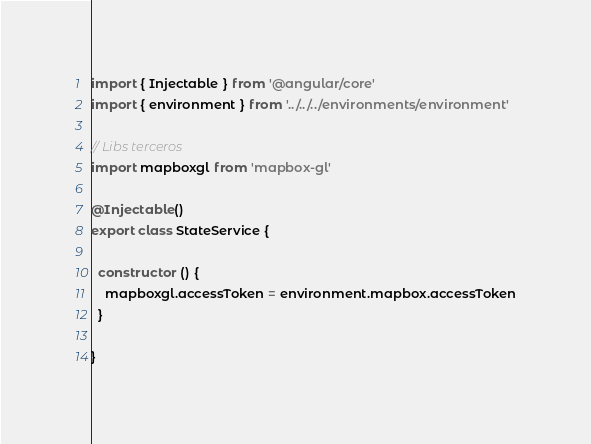Convert code to text. <code><loc_0><loc_0><loc_500><loc_500><_TypeScript_>import { Injectable } from '@angular/core'
import { environment } from '../../../environments/environment'

// Libs terceros
import mapboxgl from 'mapbox-gl'

@Injectable()
export class StateService {

  constructor () {
    mapboxgl.accessToken = environment.mapbox.accessToken
  }

}
</code> 